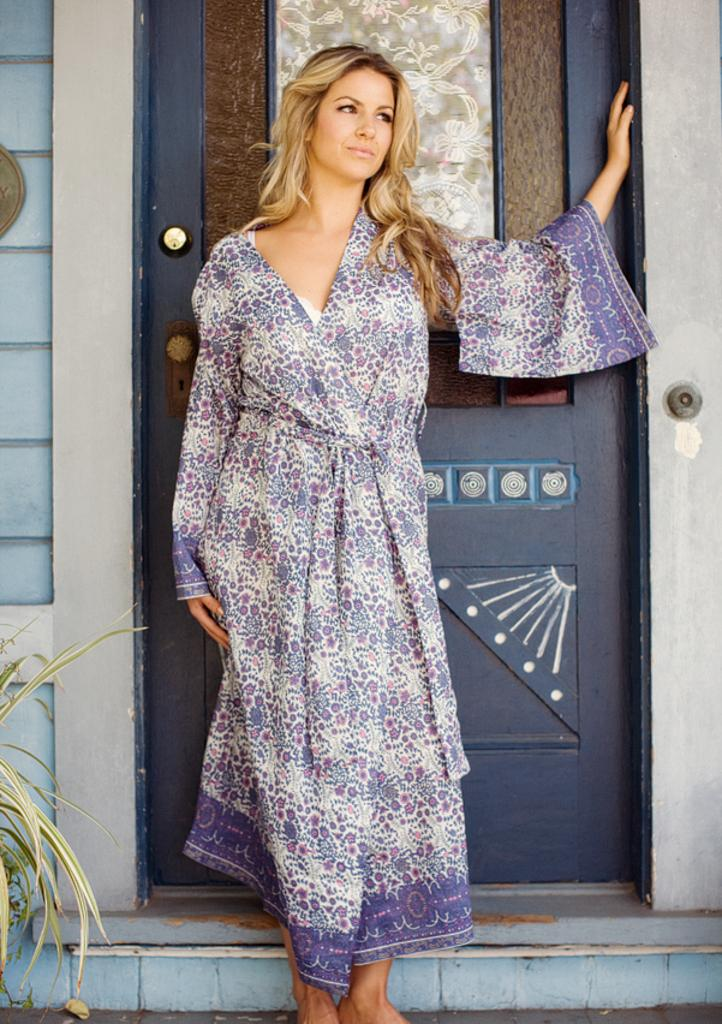What is the main subject in the image? There is a woman standing in the image. What can be seen in the foreground of the image? Leaves are visible in the image. What is in the background of the image? There is a wall and a door in the background of the image. Where is the pig located in the image? There is no pig present in the image. What type of idea is being expressed by the woman in the image? The image does not convey any specific ideas or expressions; it simply shows a woman standing with leaves in the foreground and a wall and door in the background. 